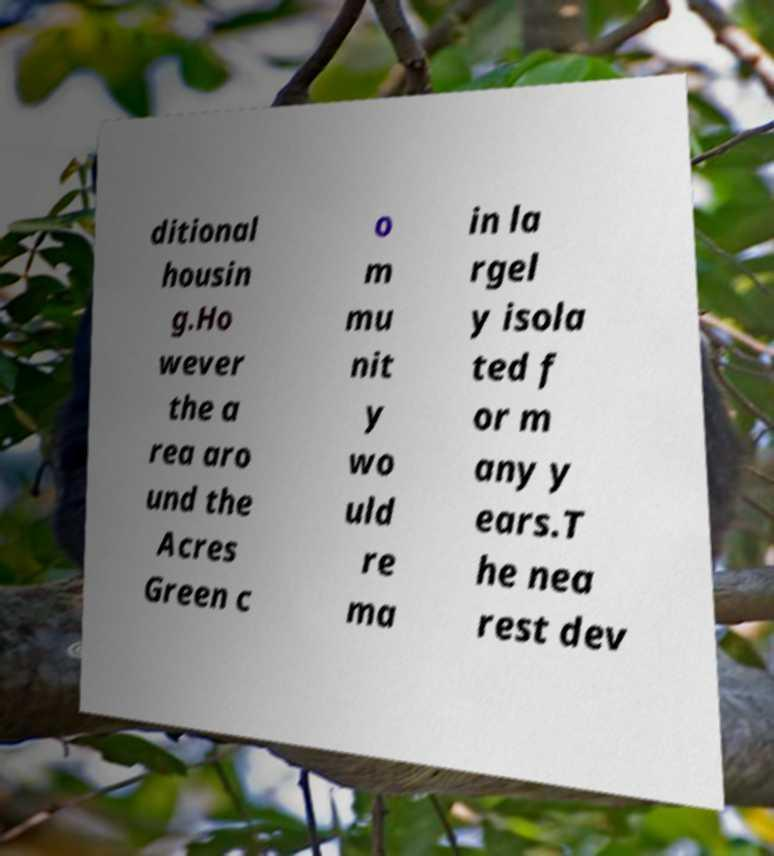Please identify and transcribe the text found in this image. ditional housin g.Ho wever the a rea aro und the Acres Green c o m mu nit y wo uld re ma in la rgel y isola ted f or m any y ears.T he nea rest dev 